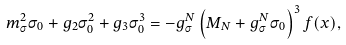Convert formula to latex. <formula><loc_0><loc_0><loc_500><loc_500>m _ { \sigma } ^ { 2 } \sigma _ { 0 } + g _ { 2 } \sigma _ { 0 } ^ { 2 } + g _ { 3 } \sigma _ { 0 } ^ { 3 } = - g _ { \sigma } ^ { N } \left ( M _ { N } + g _ { \sigma } ^ { N } \sigma _ { 0 } \right ) ^ { 3 } f ( x ) ,</formula> 